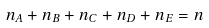Convert formula to latex. <formula><loc_0><loc_0><loc_500><loc_500>n _ { A } + n _ { B } + n _ { C } + n _ { D } + n _ { E } = n</formula> 